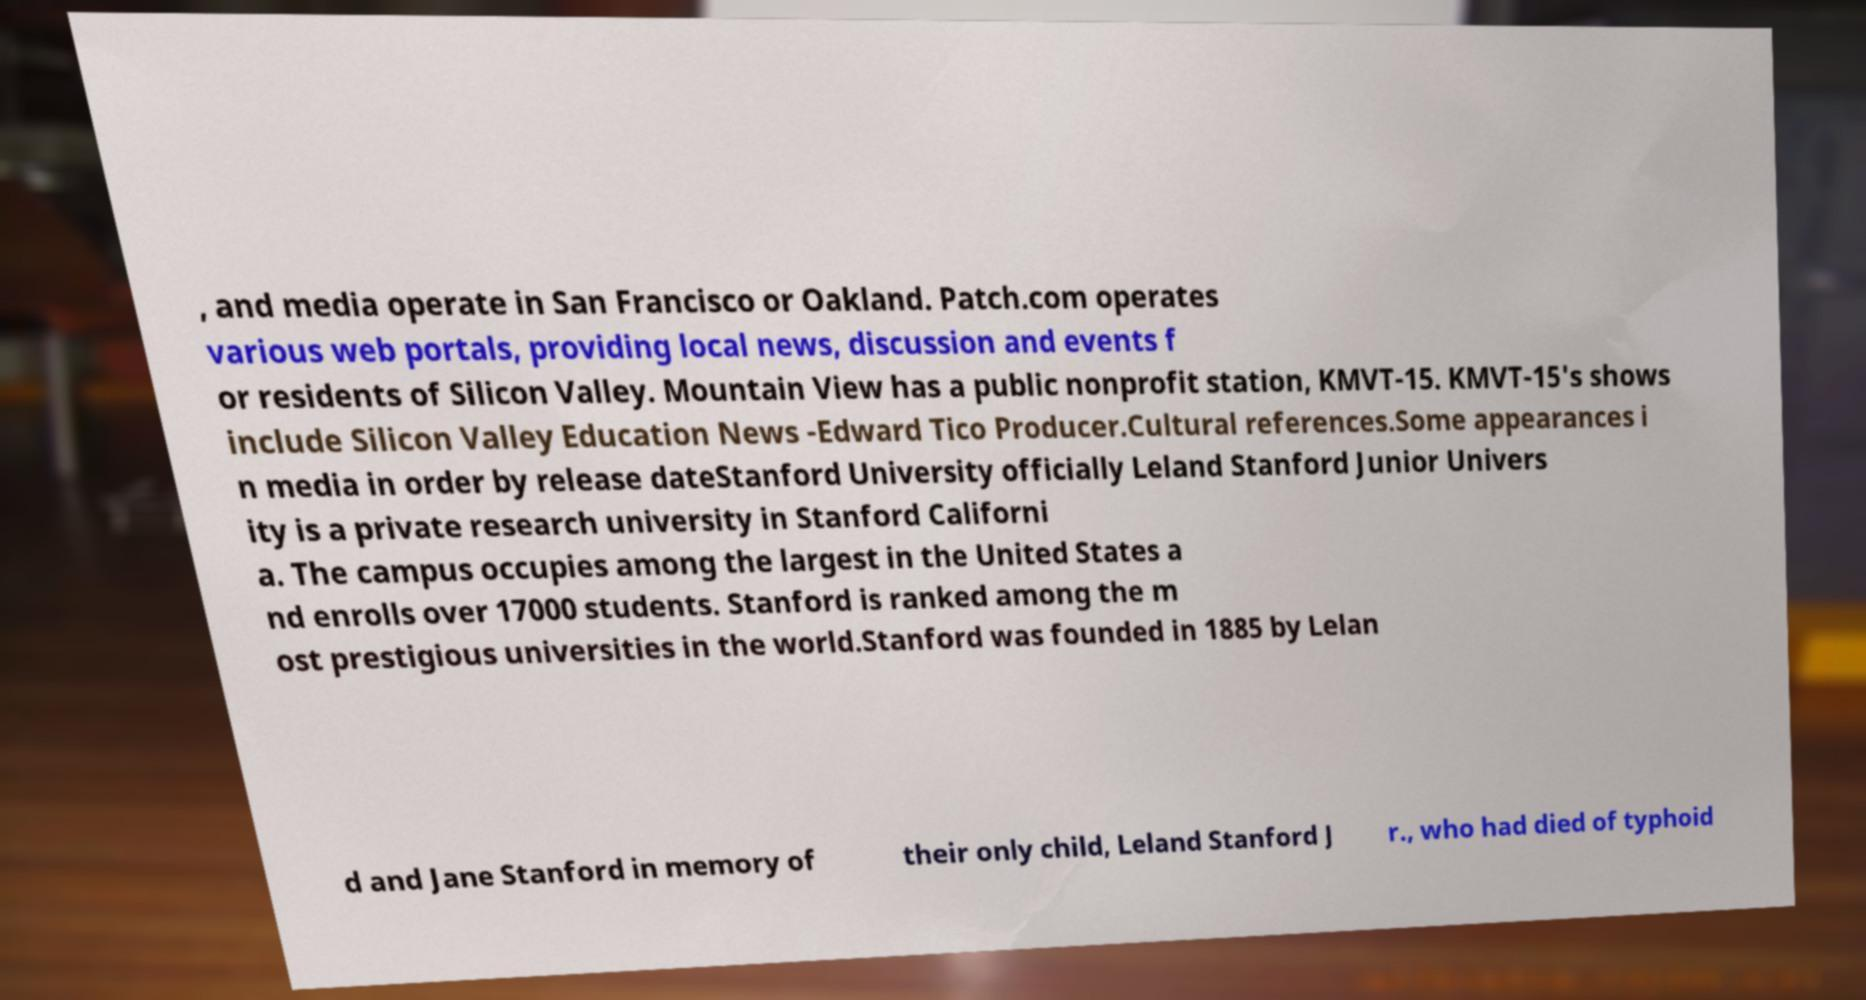Please read and relay the text visible in this image. What does it say? , and media operate in San Francisco or Oakland. Patch.com operates various web portals, providing local news, discussion and events f or residents of Silicon Valley. Mountain View has a public nonprofit station, KMVT-15. KMVT-15's shows include Silicon Valley Education News -Edward Tico Producer.Cultural references.Some appearances i n media in order by release dateStanford University officially Leland Stanford Junior Univers ity is a private research university in Stanford Californi a. The campus occupies among the largest in the United States a nd enrolls over 17000 students. Stanford is ranked among the m ost prestigious universities in the world.Stanford was founded in 1885 by Lelan d and Jane Stanford in memory of their only child, Leland Stanford J r., who had died of typhoid 